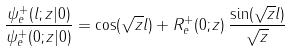<formula> <loc_0><loc_0><loc_500><loc_500>\frac { \psi _ { e } ^ { + } ( l ; z | 0 ) } { \psi _ { e } ^ { + } ( 0 ; z | 0 ) } = \cos ( \sqrt { z } l ) + R ^ { + } _ { e } ( 0 ; z ) \, \frac { \sin ( \sqrt { z } l ) } { \sqrt { z } }</formula> 